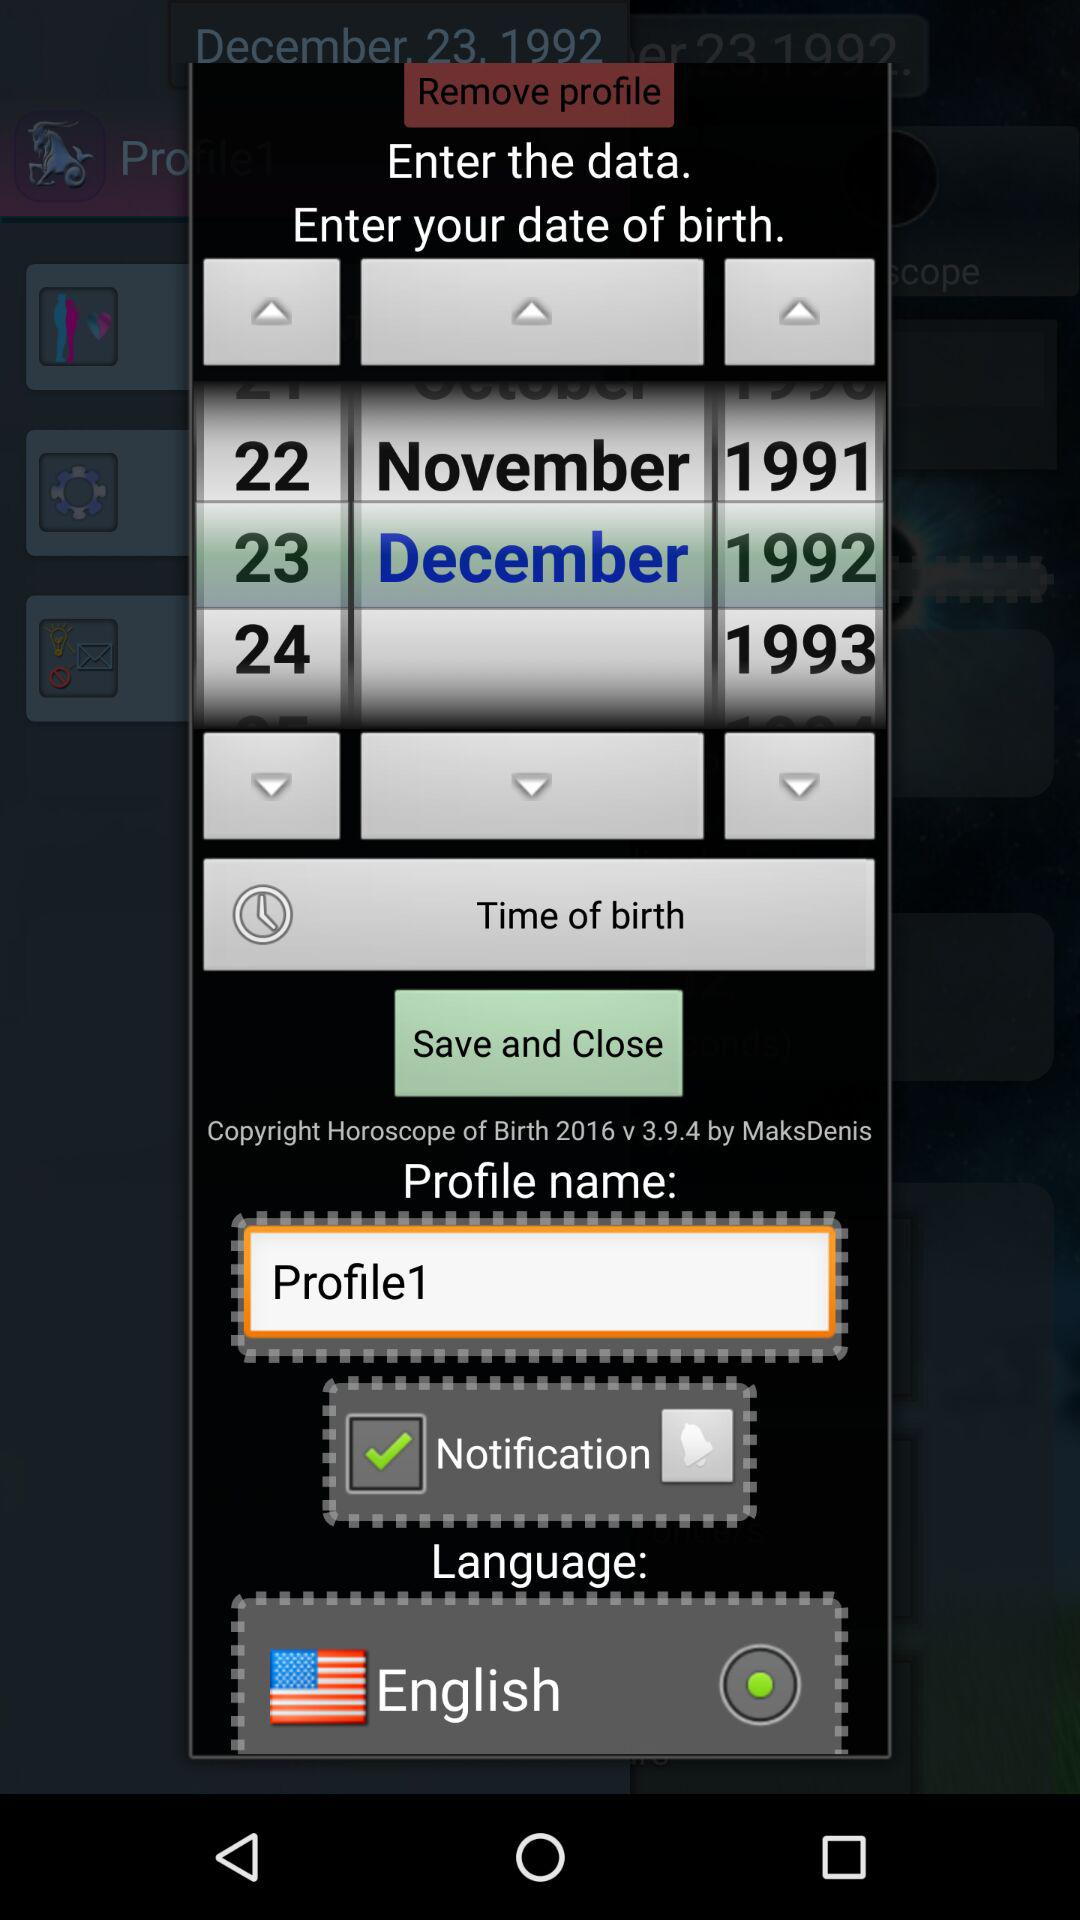Which language is chosen? The chosen language is English. 